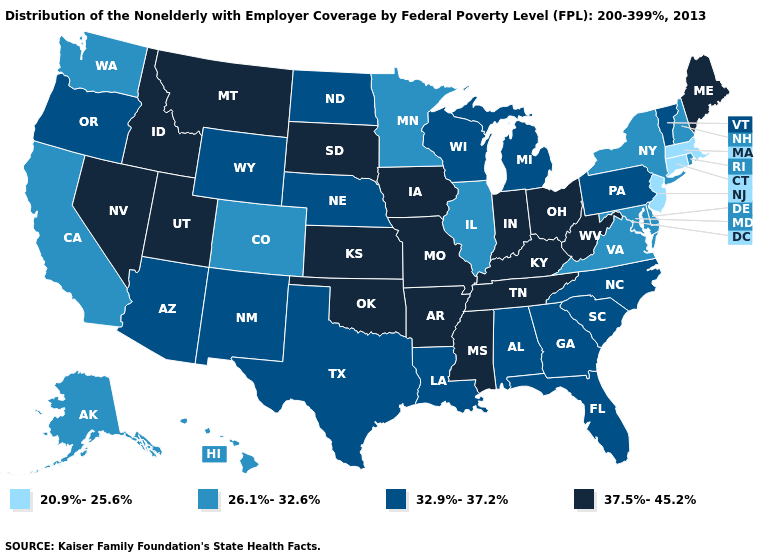Name the states that have a value in the range 20.9%-25.6%?
Be succinct. Connecticut, Massachusetts, New Jersey. What is the value of Georgia?
Short answer required. 32.9%-37.2%. What is the value of Mississippi?
Concise answer only. 37.5%-45.2%. Among the states that border Arizona , which have the highest value?
Quick response, please. Nevada, Utah. Does the first symbol in the legend represent the smallest category?
Answer briefly. Yes. Which states have the highest value in the USA?
Concise answer only. Arkansas, Idaho, Indiana, Iowa, Kansas, Kentucky, Maine, Mississippi, Missouri, Montana, Nevada, Ohio, Oklahoma, South Dakota, Tennessee, Utah, West Virginia. Does Michigan have a lower value than Tennessee?
Answer briefly. Yes. Which states have the lowest value in the South?
Keep it brief. Delaware, Maryland, Virginia. What is the value of Illinois?
Be succinct. 26.1%-32.6%. Does North Dakota have a higher value than New Hampshire?
Give a very brief answer. Yes. Which states have the lowest value in the Northeast?
Short answer required. Connecticut, Massachusetts, New Jersey. Name the states that have a value in the range 20.9%-25.6%?
Quick response, please. Connecticut, Massachusetts, New Jersey. What is the value of Illinois?
Give a very brief answer. 26.1%-32.6%. Does the map have missing data?
Answer briefly. No. How many symbols are there in the legend?
Keep it brief. 4. 